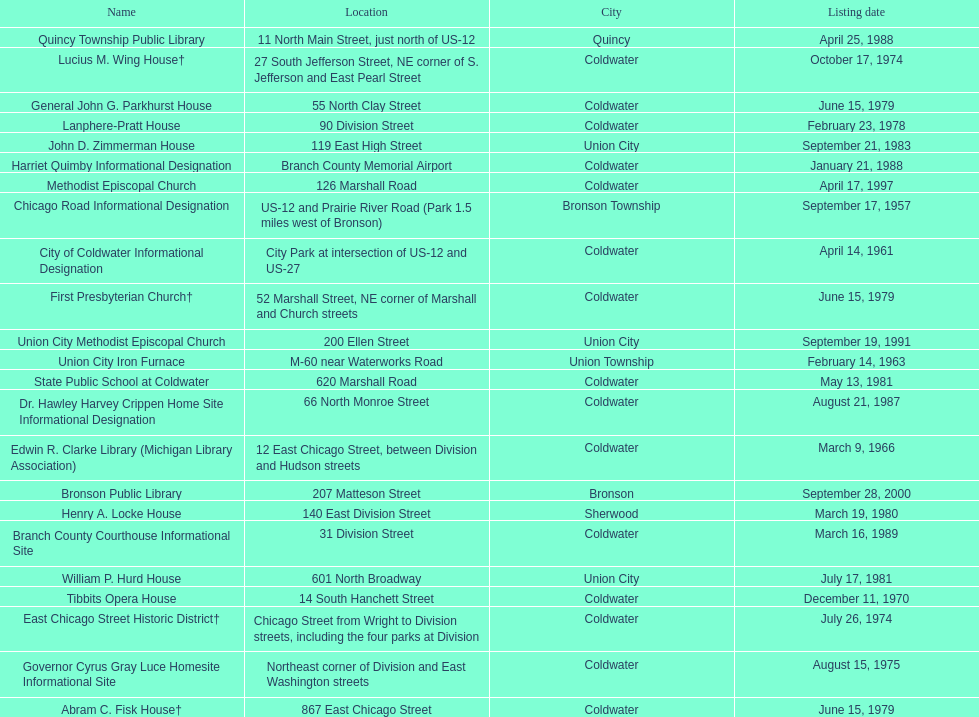How many sites were listed as historical before 1980? 12. 